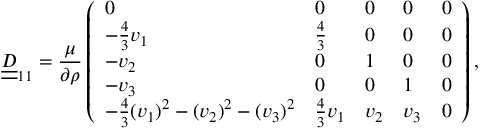<formula> <loc_0><loc_0><loc_500><loc_500>\underline { { \underline { D } } } _ { 1 1 } = \frac { \mu } { \partial \rho } \left ( \begin{array} { l l l l l } { 0 } & { 0 } & { 0 } & { 0 } & { 0 } \\ { - \frac { 4 } { 3 } v _ { 1 } } & { \frac { 4 } { 3 } } & { 0 } & { 0 } & { 0 } \\ { - v _ { 2 } } & { 0 } & { 1 } & { 0 } & { 0 } \\ { - v _ { 3 } } & { 0 } & { 0 } & { 1 } & { 0 } \\ { - \frac { 4 } { 3 } ( v _ { 1 } ) ^ { 2 } - ( v _ { 2 } ) ^ { 2 } - ( v _ { 3 } ) ^ { 2 } } & { \frac { 4 } { 3 } v _ { 1 } } & { v _ { 2 } } & { v _ { 3 } } & { 0 } \end{array} \right ) ,</formula> 